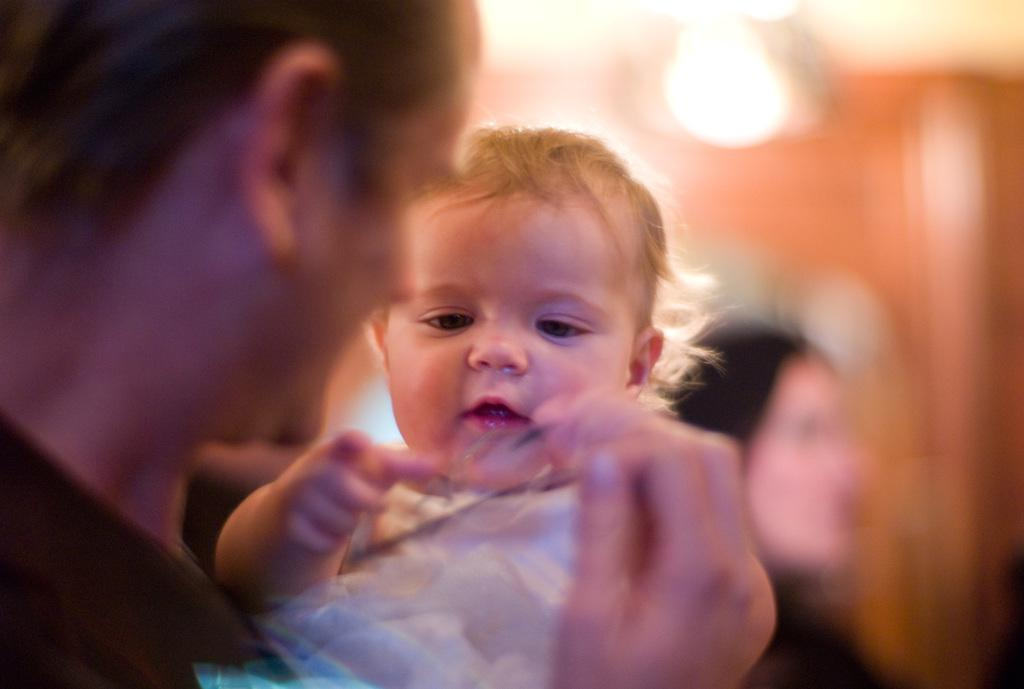What is the main subject of the image? There is a person holding a baby in the image. Can you describe the secondary subject in the image? There is another person visible in the background of the image. Where is the light source located in the image? The light source is at the top of the image. How would you describe the quality of the image? The image is blurry. What type of corn can be seen growing in the image? There is no corn present in the image. What time of day is depicted in the image? The provided facts do not mention the time of day, so it cannot be determined from the image. 